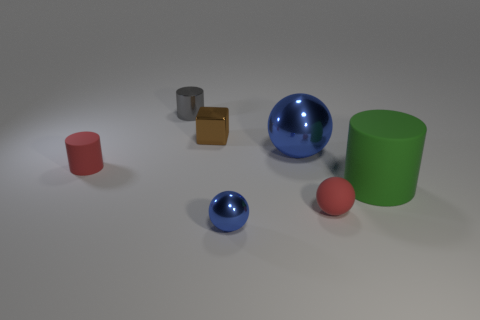There is another object that is the same color as the large shiny object; what is its shape?
Your answer should be very brief. Sphere. What size is the other ball that is the same color as the small shiny sphere?
Your response must be concise. Large. What number of tiny brown metal cubes are in front of the small sphere on the right side of the metallic object in front of the tiny rubber ball?
Provide a succinct answer. 0. There is a matte cylinder to the left of the large green cylinder; what is its color?
Provide a short and direct response. Red. Do the tiny sphere on the left side of the big blue sphere and the big matte object have the same color?
Make the answer very short. No. What size is the red thing that is the same shape as the gray metallic thing?
Provide a succinct answer. Small. Is there anything else that is the same size as the shiny cylinder?
Your response must be concise. Yes. There is a ball right of the big thing that is behind the cylinder on the right side of the small gray shiny cylinder; what is its material?
Your answer should be compact. Rubber. Are there more small objects that are left of the red matte ball than red balls behind the big metallic thing?
Give a very brief answer. Yes. Does the gray cylinder have the same size as the matte ball?
Provide a short and direct response. Yes. 